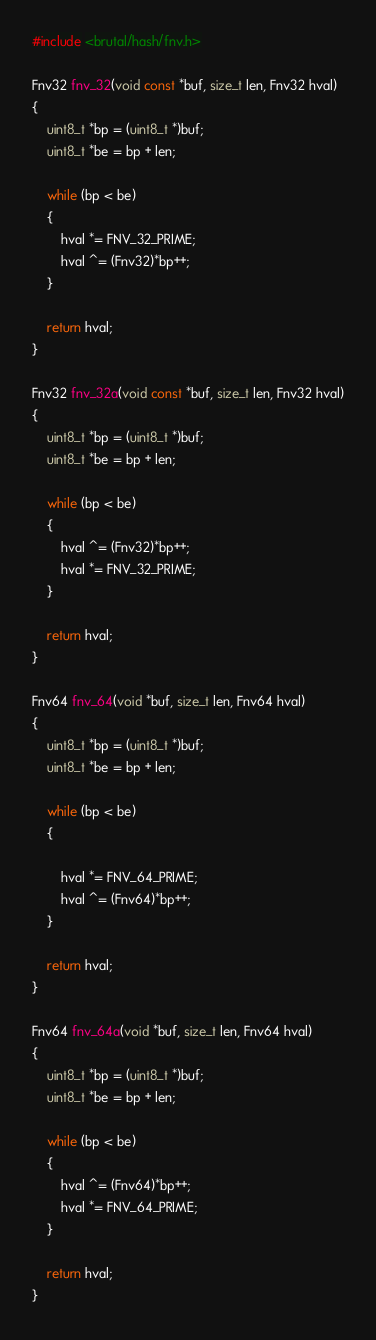Convert code to text. <code><loc_0><loc_0><loc_500><loc_500><_C_>#include <brutal/hash/fnv.h>

Fnv32 fnv_32(void const *buf, size_t len, Fnv32 hval)
{
    uint8_t *bp = (uint8_t *)buf;
    uint8_t *be = bp + len;

    while (bp < be)
    {
        hval *= FNV_32_PRIME;
        hval ^= (Fnv32)*bp++;
    }

    return hval;
}

Fnv32 fnv_32a(void const *buf, size_t len, Fnv32 hval)
{
    uint8_t *bp = (uint8_t *)buf;
    uint8_t *be = bp + len;

    while (bp < be)
    {
        hval ^= (Fnv32)*bp++;
        hval *= FNV_32_PRIME;
    }

    return hval;
}

Fnv64 fnv_64(void *buf, size_t len, Fnv64 hval)
{
    uint8_t *bp = (uint8_t *)buf;
    uint8_t *be = bp + len;

    while (bp < be)
    {

        hval *= FNV_64_PRIME;
        hval ^= (Fnv64)*bp++;
    }

    return hval;
}

Fnv64 fnv_64a(void *buf, size_t len, Fnv64 hval)
{
    uint8_t *bp = (uint8_t *)buf;
    uint8_t *be = bp + len;

    while (bp < be)
    {
        hval ^= (Fnv64)*bp++;
        hval *= FNV_64_PRIME;
    }

    return hval;
}
</code> 